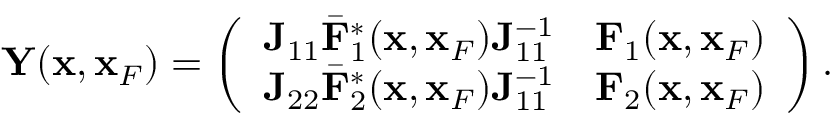<formula> <loc_0><loc_0><loc_500><loc_500>\begin{array} { r } { { Y } ( { x } , { x } _ { F } ) = \left ( \begin{array} { l l } { { J } _ { 1 1 } { { \bar { F } } } _ { 1 } ^ { * } ( { x } , { x } _ { F } ) { J } _ { 1 1 } ^ { - 1 } } & { { F } _ { 1 } ( { x } , { x } _ { F } ) } \\ { { J } _ { 2 2 } { { \bar { F } } } _ { 2 } ^ { * } ( { x } , { x } _ { F } ) { J } _ { 1 1 } ^ { - 1 } } & { { F } _ { 2 } ( { x } , { x } _ { F } ) } \end{array} \right ) . } \end{array}</formula> 